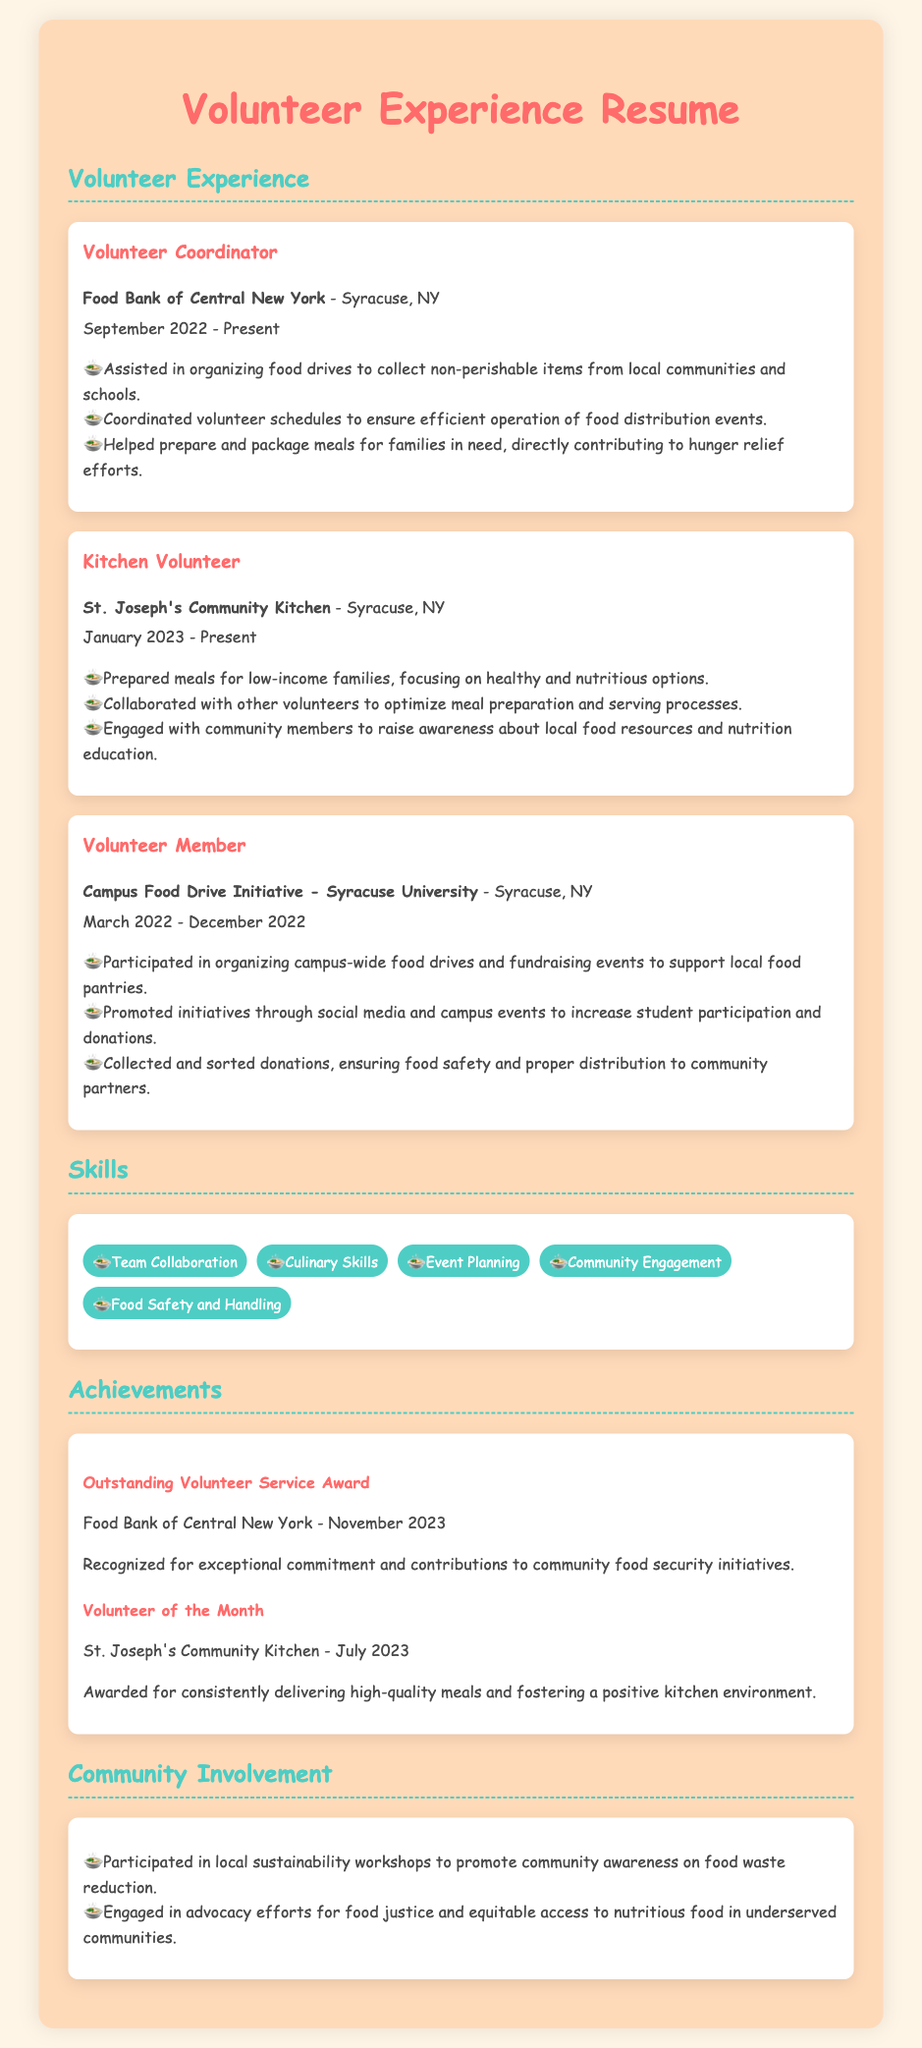What is the title of the document? The title of the document is found at the top of the resume, indicating the focus on volunteer experience.
Answer: Volunteer Experience Resume Who is the Volunteer Coordinator? This is the first experience listed, providing the name and role held by the individual in the organization.
Answer: Food Bank of Central New York When did the individual start volunteering at St. Joseph's Community Kitchen? The start date for this volunteer position is provided in the experience section.
Answer: January 2023 What award did the individual receive in November 2023? The achievements section highlights various awards received, specifically mentioning the award in November 2023.
Answer: Outstanding Volunteer Service Award How many skills are listed in the skills section? The skills section contains a list, and counting these items reveals the total number.
Answer: Five What type of meals did the individual prepare as a Kitchen Volunteer? This is specified in the experience description under the Kitchen Volunteer role.
Answer: Healthy and nutritious options Which organization conducted the Campus Food Drive Initiative? The experience section mentions the specific campus initiative that the individual participated in.
Answer: Syracuse University What was the purpose of the local sustainability workshops? This is described in the community involvement section by stating the main goal of participation.
Answer: Food waste reduction Which month in 2023 did the individual receive the 'Volunteer of the Month' award? The achievements section specifies the month for this recognition.
Answer: July 